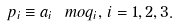Convert formula to latex. <formula><loc_0><loc_0><loc_500><loc_500>p _ { i } \equiv a _ { i } \ m o q _ { i } , \, i = 1 , 2 , 3 .</formula> 